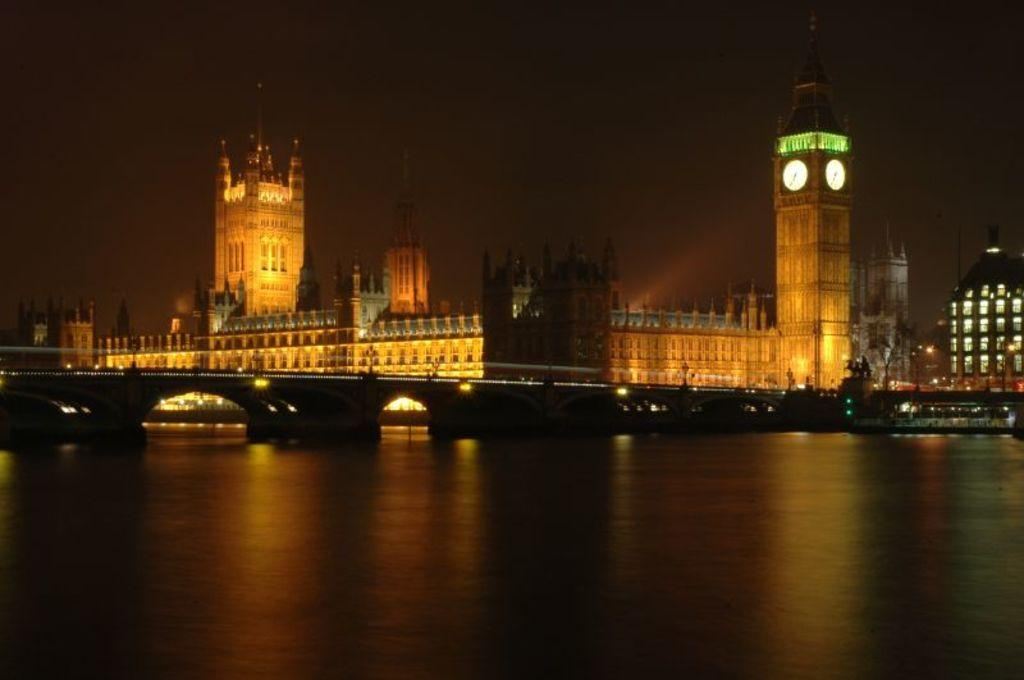What structure can be seen in the image? There is a bridge in the image. What is on the water near the bridge? There is a boat on the water in the image. What can be seen in the distance behind the bridge? There are buildings, lights, a statue, and some objects in the background of the image. What part of the natural environment is visible in the image? The sky is visible in the background of the image. What type of stamp can be seen on the boat in the image? There is no stamp present on the boat in the image. How does the statue burn in the image? The statue does not burn in the image; it is a stationary object in the background. 